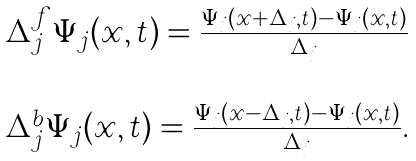<formula> <loc_0><loc_0><loc_500><loc_500>\begin{array} { c } \Delta ^ { f } _ { j } \Psi _ { j } ( x , t ) = \frac { \Psi _ { j } ( x + \Delta _ { j } , t ) - \Psi _ { j } ( x , t ) } { \Delta _ { j } } \\ \\ \Delta ^ { b } _ { j } \Psi _ { j } ( x , t ) = \frac { \Psi _ { j } ( x - \Delta _ { j } , t ) - \Psi _ { j } ( x , t ) } { \Delta _ { j } } . \end{array}</formula> 